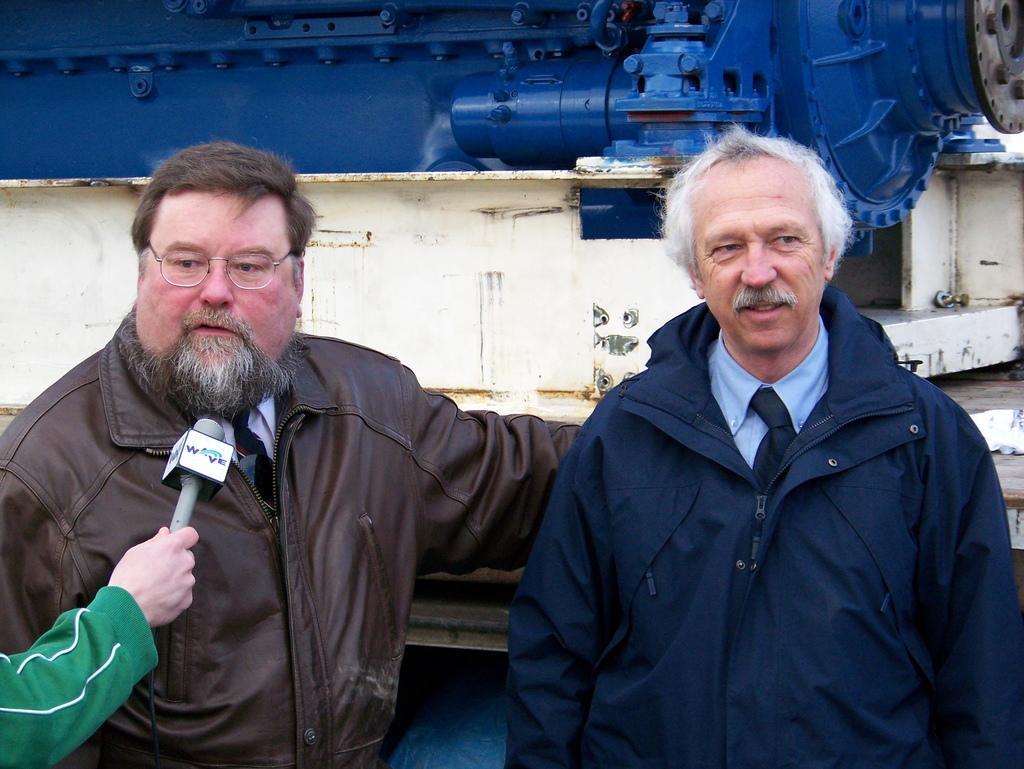How would you summarize this image in a sentence or two? On the left side, there is a person in a brown color jacket, wearing a spectacle and speaking. In front of him, there is a person in a green color jacket, holding a mic. On the right side, there is a person in a violet color jacket, smiling and standing. In the background, there is an object. 